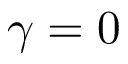<formula> <loc_0><loc_0><loc_500><loc_500>\gamma = 0</formula> 